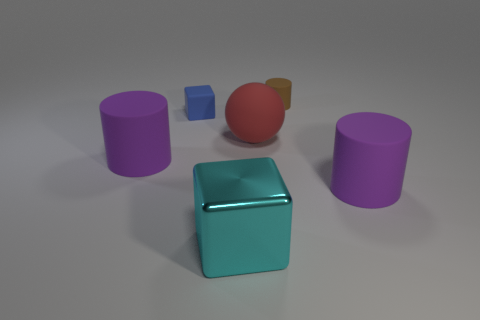Are any cyan metal things visible?
Keep it short and to the point. Yes. There is a purple cylinder that is left of the big red matte ball; how many small brown objects are in front of it?
Give a very brief answer. 0. What shape is the matte thing that is to the left of the blue rubber object?
Ensure brevity in your answer.  Cylinder. The purple object that is to the left of the object that is in front of the large cylinder that is on the right side of the shiny thing is made of what material?
Offer a very short reply. Rubber. How many other objects are there of the same size as the shiny thing?
Ensure brevity in your answer.  3. What material is the cyan object that is the same shape as the blue thing?
Ensure brevity in your answer.  Metal. What color is the big metallic block?
Provide a succinct answer. Cyan. There is a large rubber cylinder right of the rubber cylinder on the left side of the red rubber thing; what is its color?
Your answer should be very brief. Purple. Do the small block and the big object that is on the right side of the sphere have the same color?
Offer a terse response. No. There is a large rubber thing that is right of the tiny rubber object right of the big cyan metallic object; how many rubber spheres are to the left of it?
Make the answer very short. 1. 